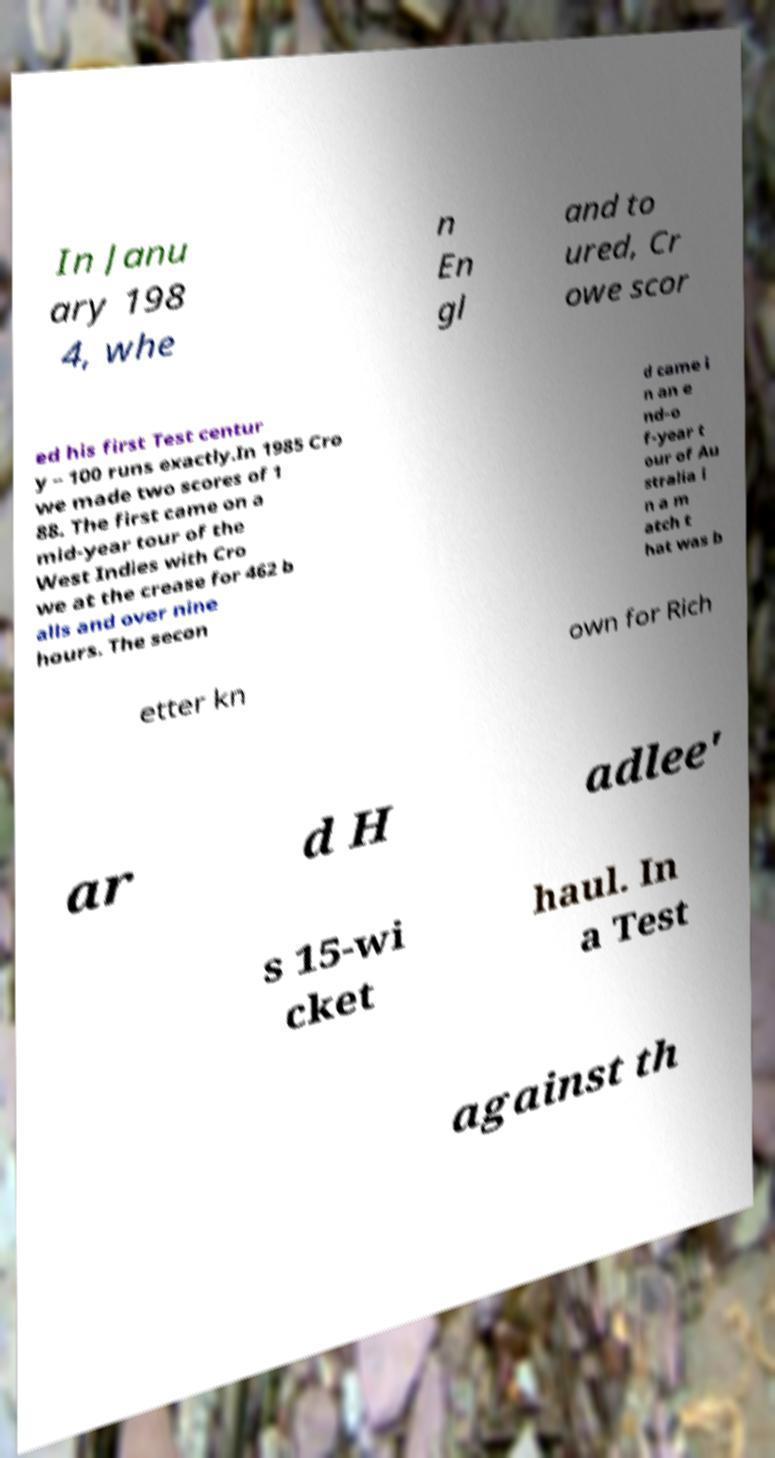Please read and relay the text visible in this image. What does it say? In Janu ary 198 4, whe n En gl and to ured, Cr owe scor ed his first Test centur y – 100 runs exactly.In 1985 Cro we made two scores of 1 88. The first came on a mid-year tour of the West Indies with Cro we at the crease for 462 b alls and over nine hours. The secon d came i n an e nd-o f-year t our of Au stralia i n a m atch t hat was b etter kn own for Rich ar d H adlee' s 15-wi cket haul. In a Test against th 